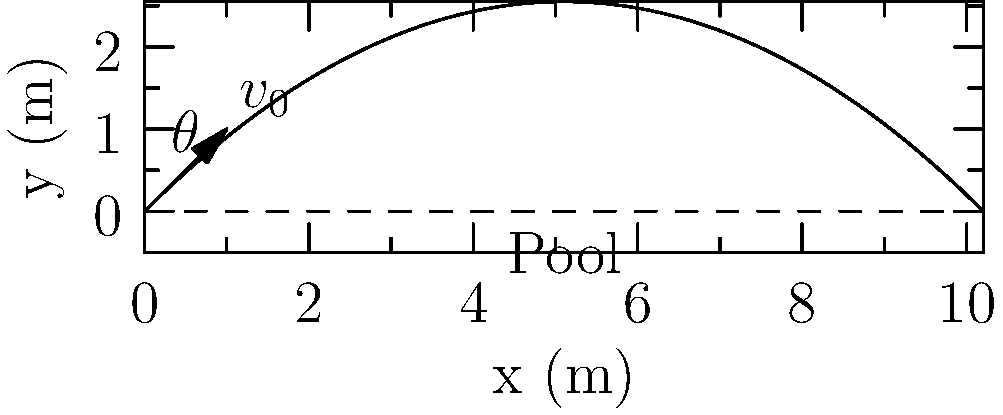In a dramatic reality show finale, a contestant is launched into a pool with an initial velocity of 10 m/s at an angle of 45° above the horizontal. Assuming no air resistance, what is the maximum height reached by the contestant before splashing into the pool? To find the maximum height, we can follow these steps:

1) The vertical component of the initial velocity is given by:
   $v_{0y} = v_0 \sin(\theta) = 10 \sin(45°) = 10 \cdot \frac{\sqrt{2}}{2} \approx 7.07$ m/s

2) The time to reach the maximum height is when the vertical velocity becomes zero:
   $t_{max} = \frac{v_{0y}}{g} = \frac{7.07}{9.8} \approx 0.72$ seconds

3) The maximum height can be calculated using the equation:
   $y_{max} = v_{0y}t - \frac{1}{2}gt^2$

4) Substituting the values:
   $y_{max} = 7.07 \cdot 0.72 - \frac{1}{2} \cdot 9.8 \cdot 0.72^2$
   $y_{max} = 5.09 - 2.54 = 2.55$ meters

Therefore, the contestant reaches a maximum height of approximately 2.55 meters.
Answer: 2.55 m 